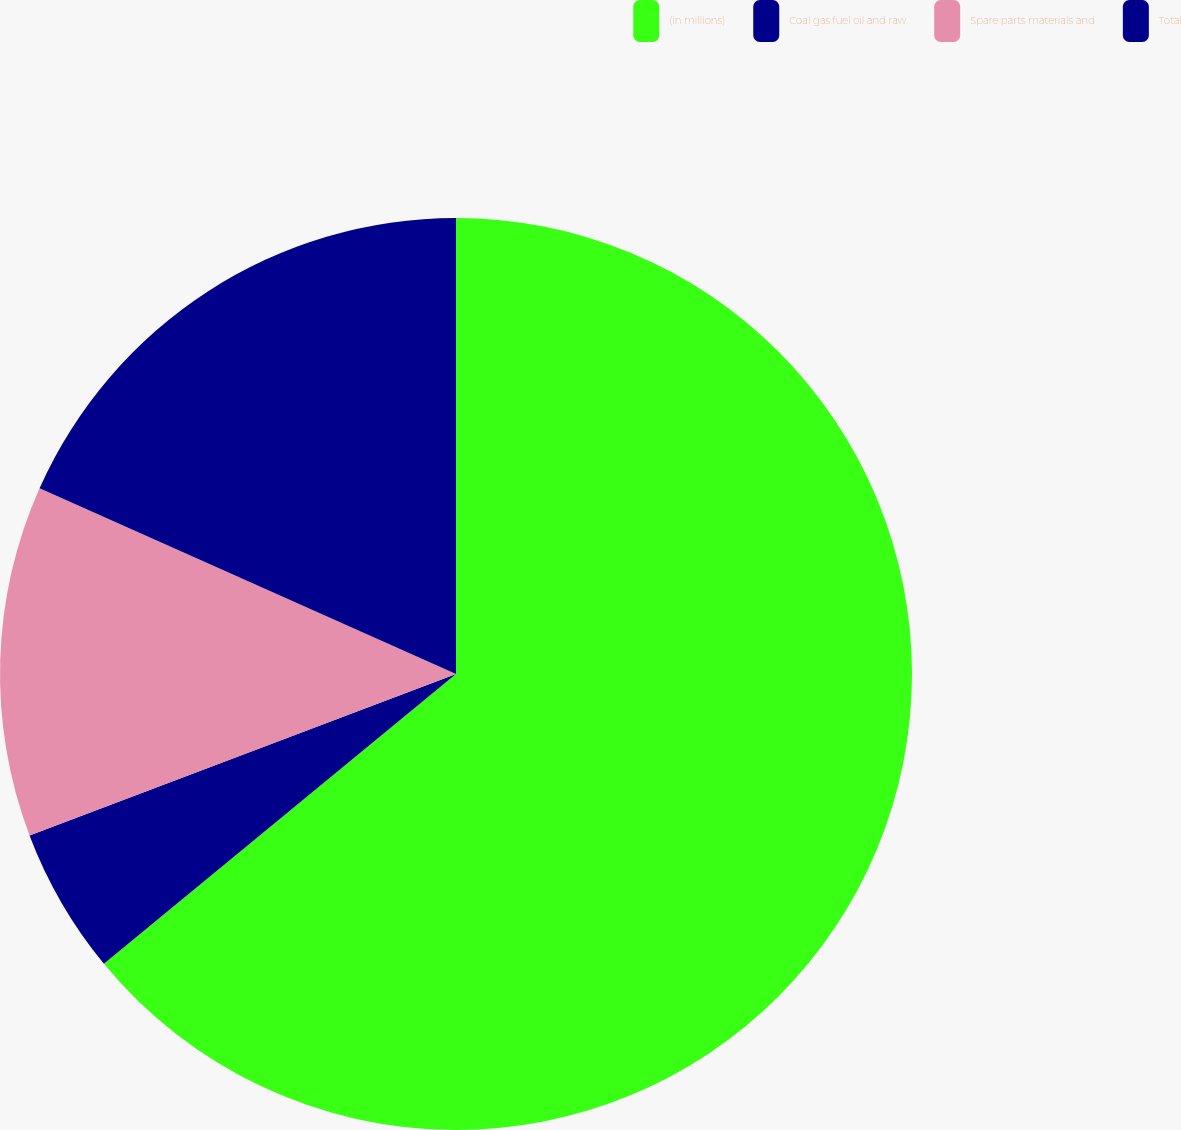<chart> <loc_0><loc_0><loc_500><loc_500><pie_chart><fcel>(in millions)<fcel>Coal gas fuel oil and raw<fcel>Spare parts materials and<fcel>Total<nl><fcel>64.04%<fcel>5.2%<fcel>12.44%<fcel>18.32%<nl></chart> 